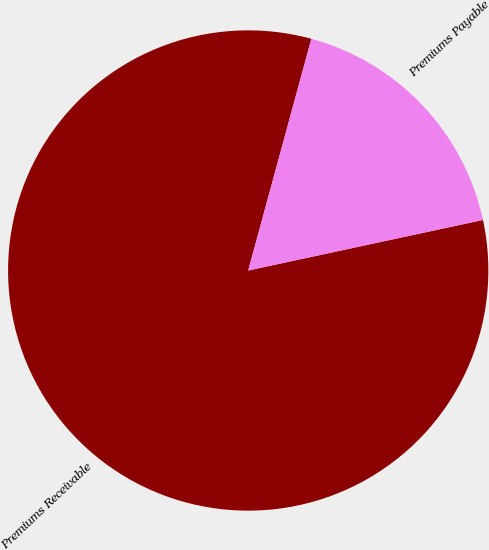<chart> <loc_0><loc_0><loc_500><loc_500><pie_chart><fcel>Premiums Receivable<fcel>Premiums Payable<nl><fcel>82.61%<fcel>17.39%<nl></chart> 